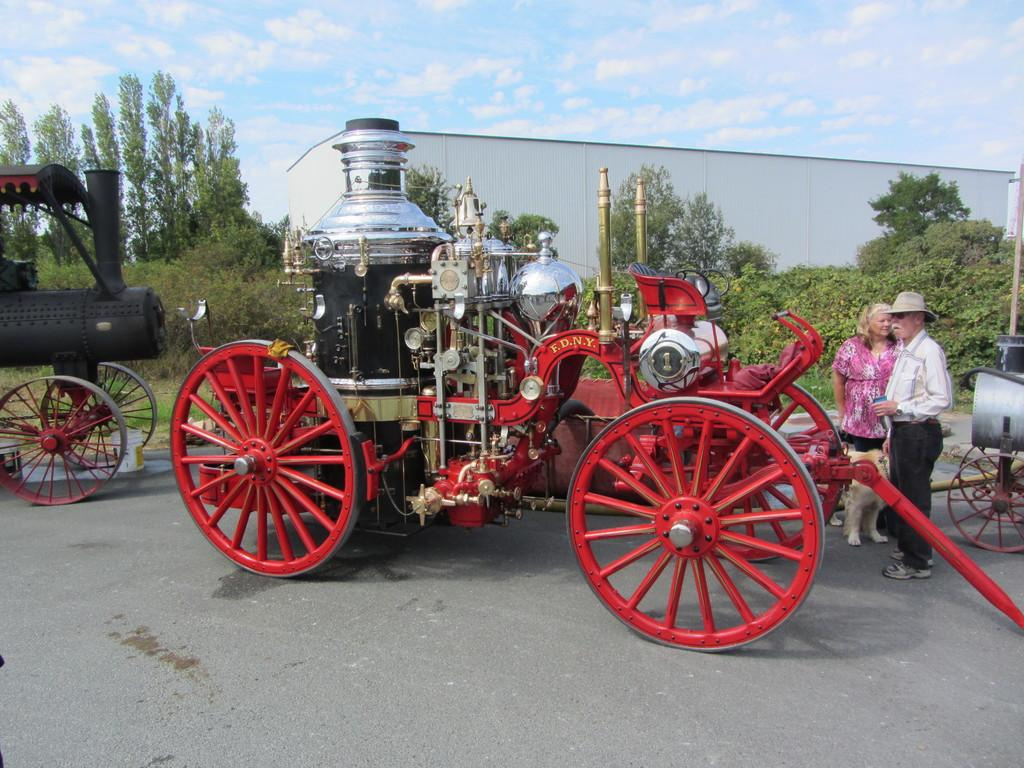What type of vehicles can be seen on the road in the image? There are four-wheeler vehicles on the road. How many people are present on the road? There are two persons on the road. What else can be seen in the image besides the vehicles and people? There is an animal visible in the image. What can be seen in the background of the image? Trees arees are present in the background of the image. What is visible in the sky in the image? Clouds are visible in the sky. What type of sign is present on the road in the image? There is no sign present on the road in the image. What kind of system is being used by the animal to communicate with the vehicles? There is no indication of any communication system between the animal and the vehicles in the image. 